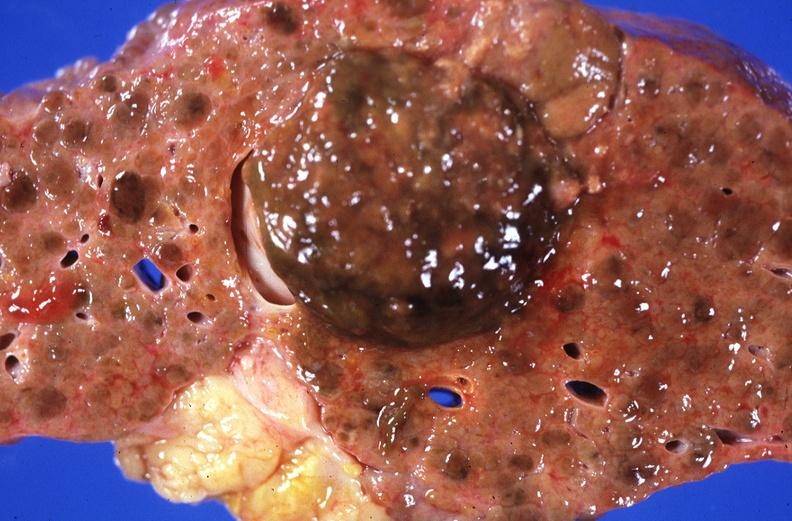s endometritis postpartum present?
Answer the question using a single word or phrase. No 